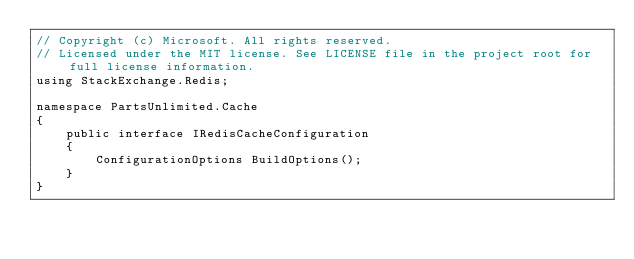<code> <loc_0><loc_0><loc_500><loc_500><_C#_>// Copyright (c) Microsoft. All rights reserved.
// Licensed under the MIT license. See LICENSE file in the project root for full license information. 
using StackExchange.Redis;

namespace PartsUnlimited.Cache
{
    public interface IRedisCacheConfiguration
    {
        ConfigurationOptions BuildOptions();
    }
}</code> 